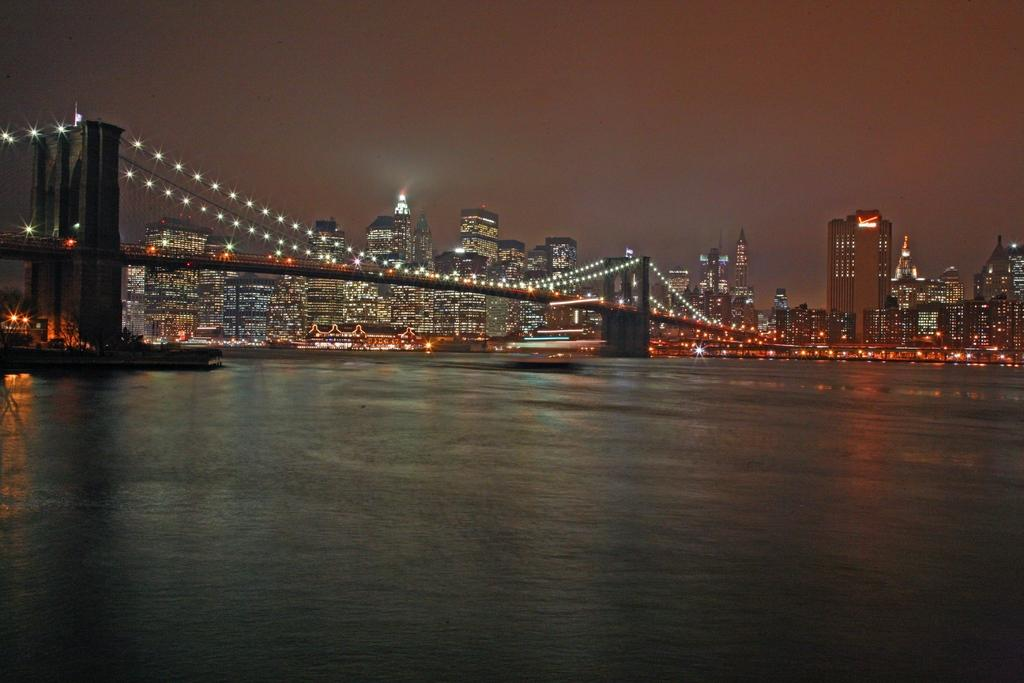What is in the foreground of the image? There is water in the foreground of the image. What structure can be seen in the middle of the image? There is a bridge in the middle of the image. What can be seen in the background of the image? There are buildings and the sky visible in the background of the image. How much paint is required to cover the bridge in the image? There is no information about paint or the need to paint the bridge in the image. Is there a beggar visible in the image? There is no mention of a beggar in the image, and no such figure can be seen. 